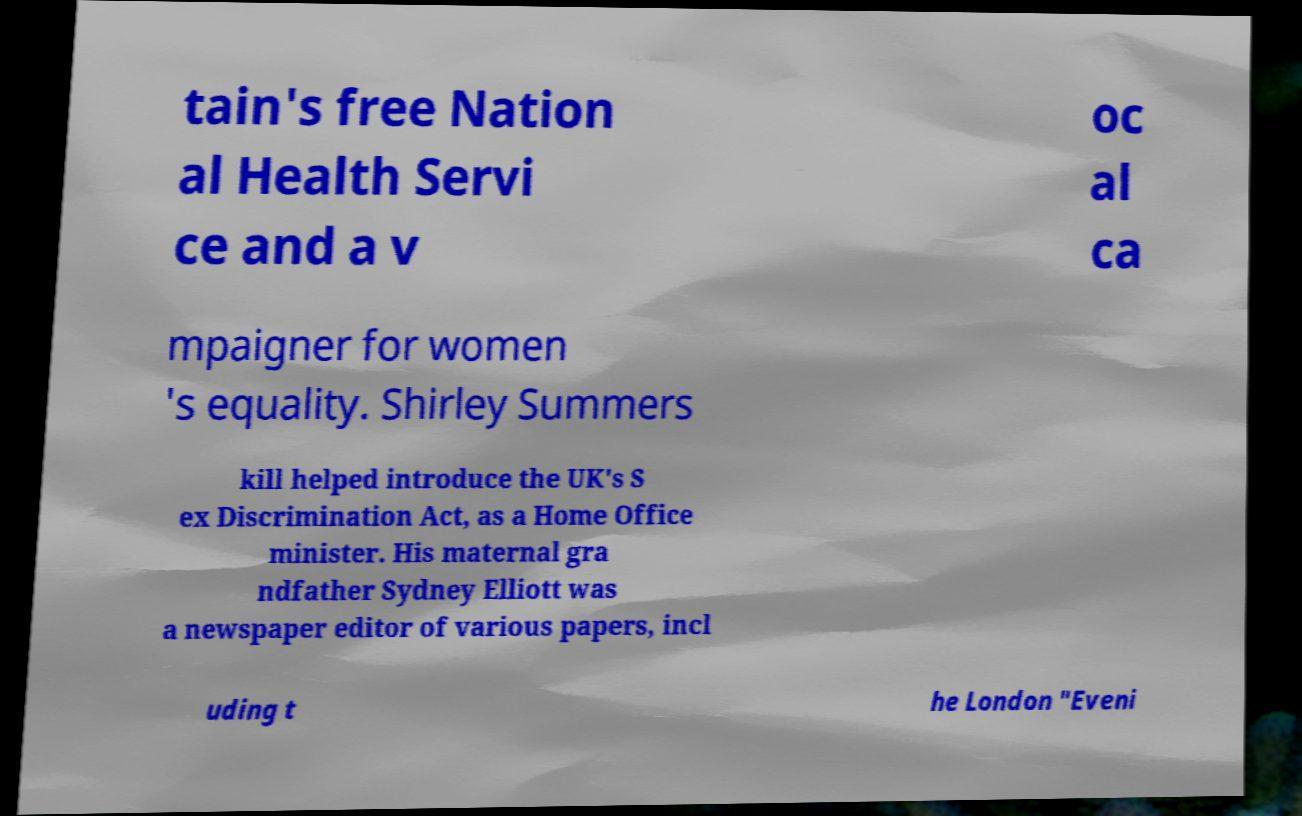I need the written content from this picture converted into text. Can you do that? tain's free Nation al Health Servi ce and a v oc al ca mpaigner for women 's equality. Shirley Summers kill helped introduce the UK's S ex Discrimination Act, as a Home Office minister. His maternal gra ndfather Sydney Elliott was a newspaper editor of various papers, incl uding t he London "Eveni 